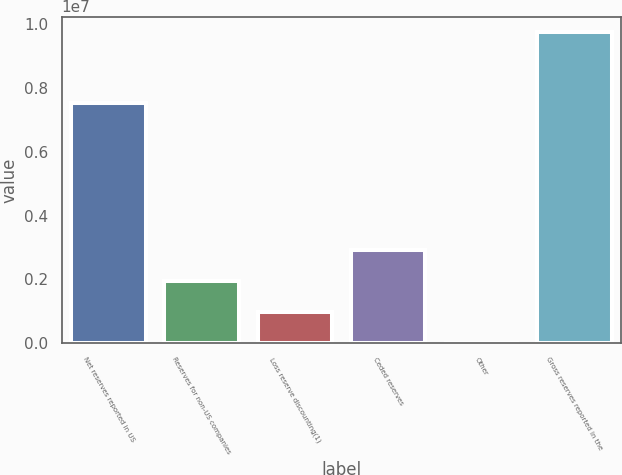Convert chart. <chart><loc_0><loc_0><loc_500><loc_500><bar_chart><fcel>Net reserves reported in US<fcel>Reserves for non-US companies<fcel>Loss reserve discounting(1)<fcel>Ceded reserves<fcel>Other<fcel>Gross reserves reported in the<nl><fcel>7.51928e+06<fcel>1.95233e+06<fcel>977486<fcel>2.92718e+06<fcel>2642<fcel>9.75109e+06<nl></chart> 